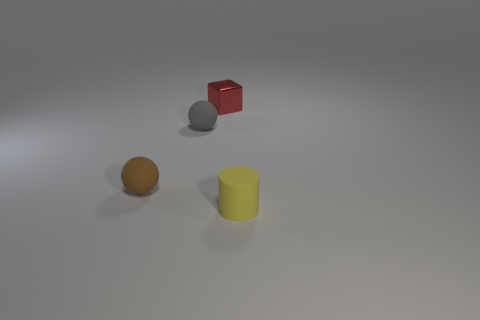Is there any other thing that is made of the same material as the red object?
Keep it short and to the point. No. What is the tiny brown object made of?
Provide a short and direct response. Rubber. There is a small ball in front of the small rubber ball behind the sphere on the left side of the gray thing; what is its material?
Your answer should be very brief. Rubber. There is a shiny thing; does it have the same color as the rubber object that is behind the small brown rubber object?
Offer a very short reply. No. Are there any other things that have the same shape as the red shiny object?
Provide a succinct answer. No. What is the color of the small sphere that is behind the small rubber ball to the left of the gray matte ball?
Keep it short and to the point. Gray. What number of tiny cyan metal objects are there?
Your response must be concise. 0. What number of shiny things are either small cylinders or tiny green spheres?
Keep it short and to the point. 0. What number of matte cylinders have the same color as the shiny object?
Your answer should be very brief. 0. What is the material of the small thing left of the sphere that is on the right side of the brown object?
Provide a succinct answer. Rubber. 